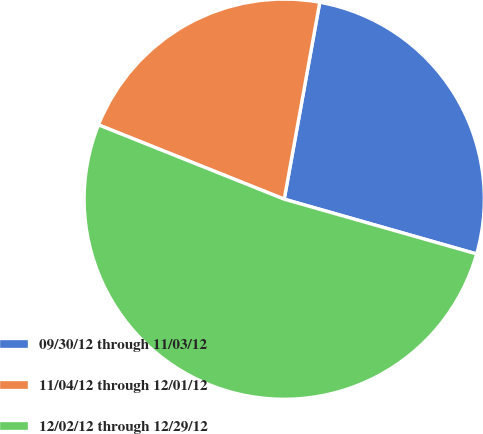<chart> <loc_0><loc_0><loc_500><loc_500><pie_chart><fcel>09/30/12 through 11/03/12<fcel>11/04/12 through 12/01/12<fcel>12/02/12 through 12/29/12<nl><fcel>26.57%<fcel>21.78%<fcel>51.64%<nl></chart> 